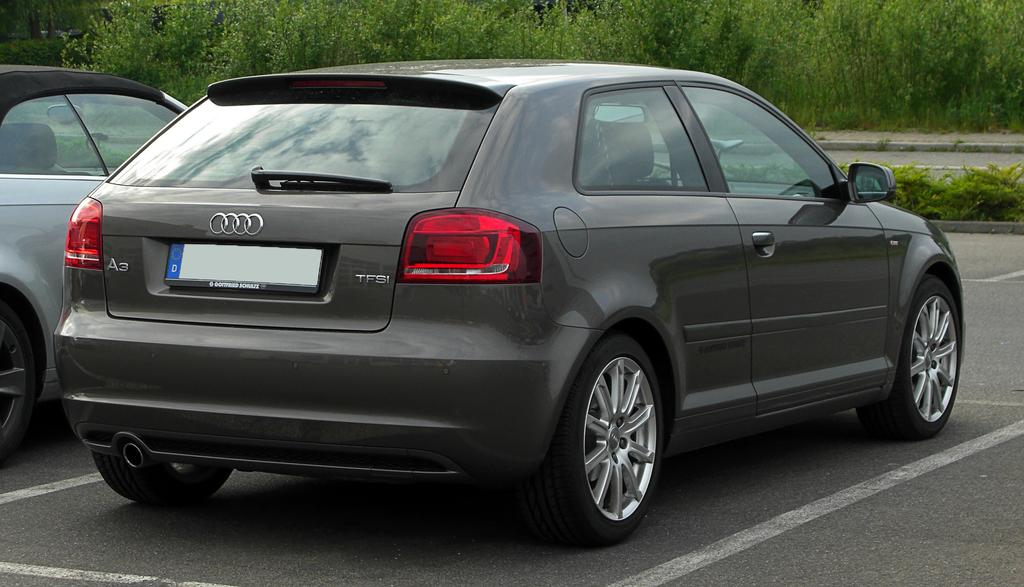What is happening on the road in the image? There are vehicles on the road in the image. What type of vegetation can be seen in the image? There are plants and trees in the image. What type of prose is being recited by the trees in the image? There is no indication in the image that the trees are reciting any prose. How do the nerves of the plants in the image appear? There is no way to determine the appearance of the plants' nerves from the image, as they are not visible. 